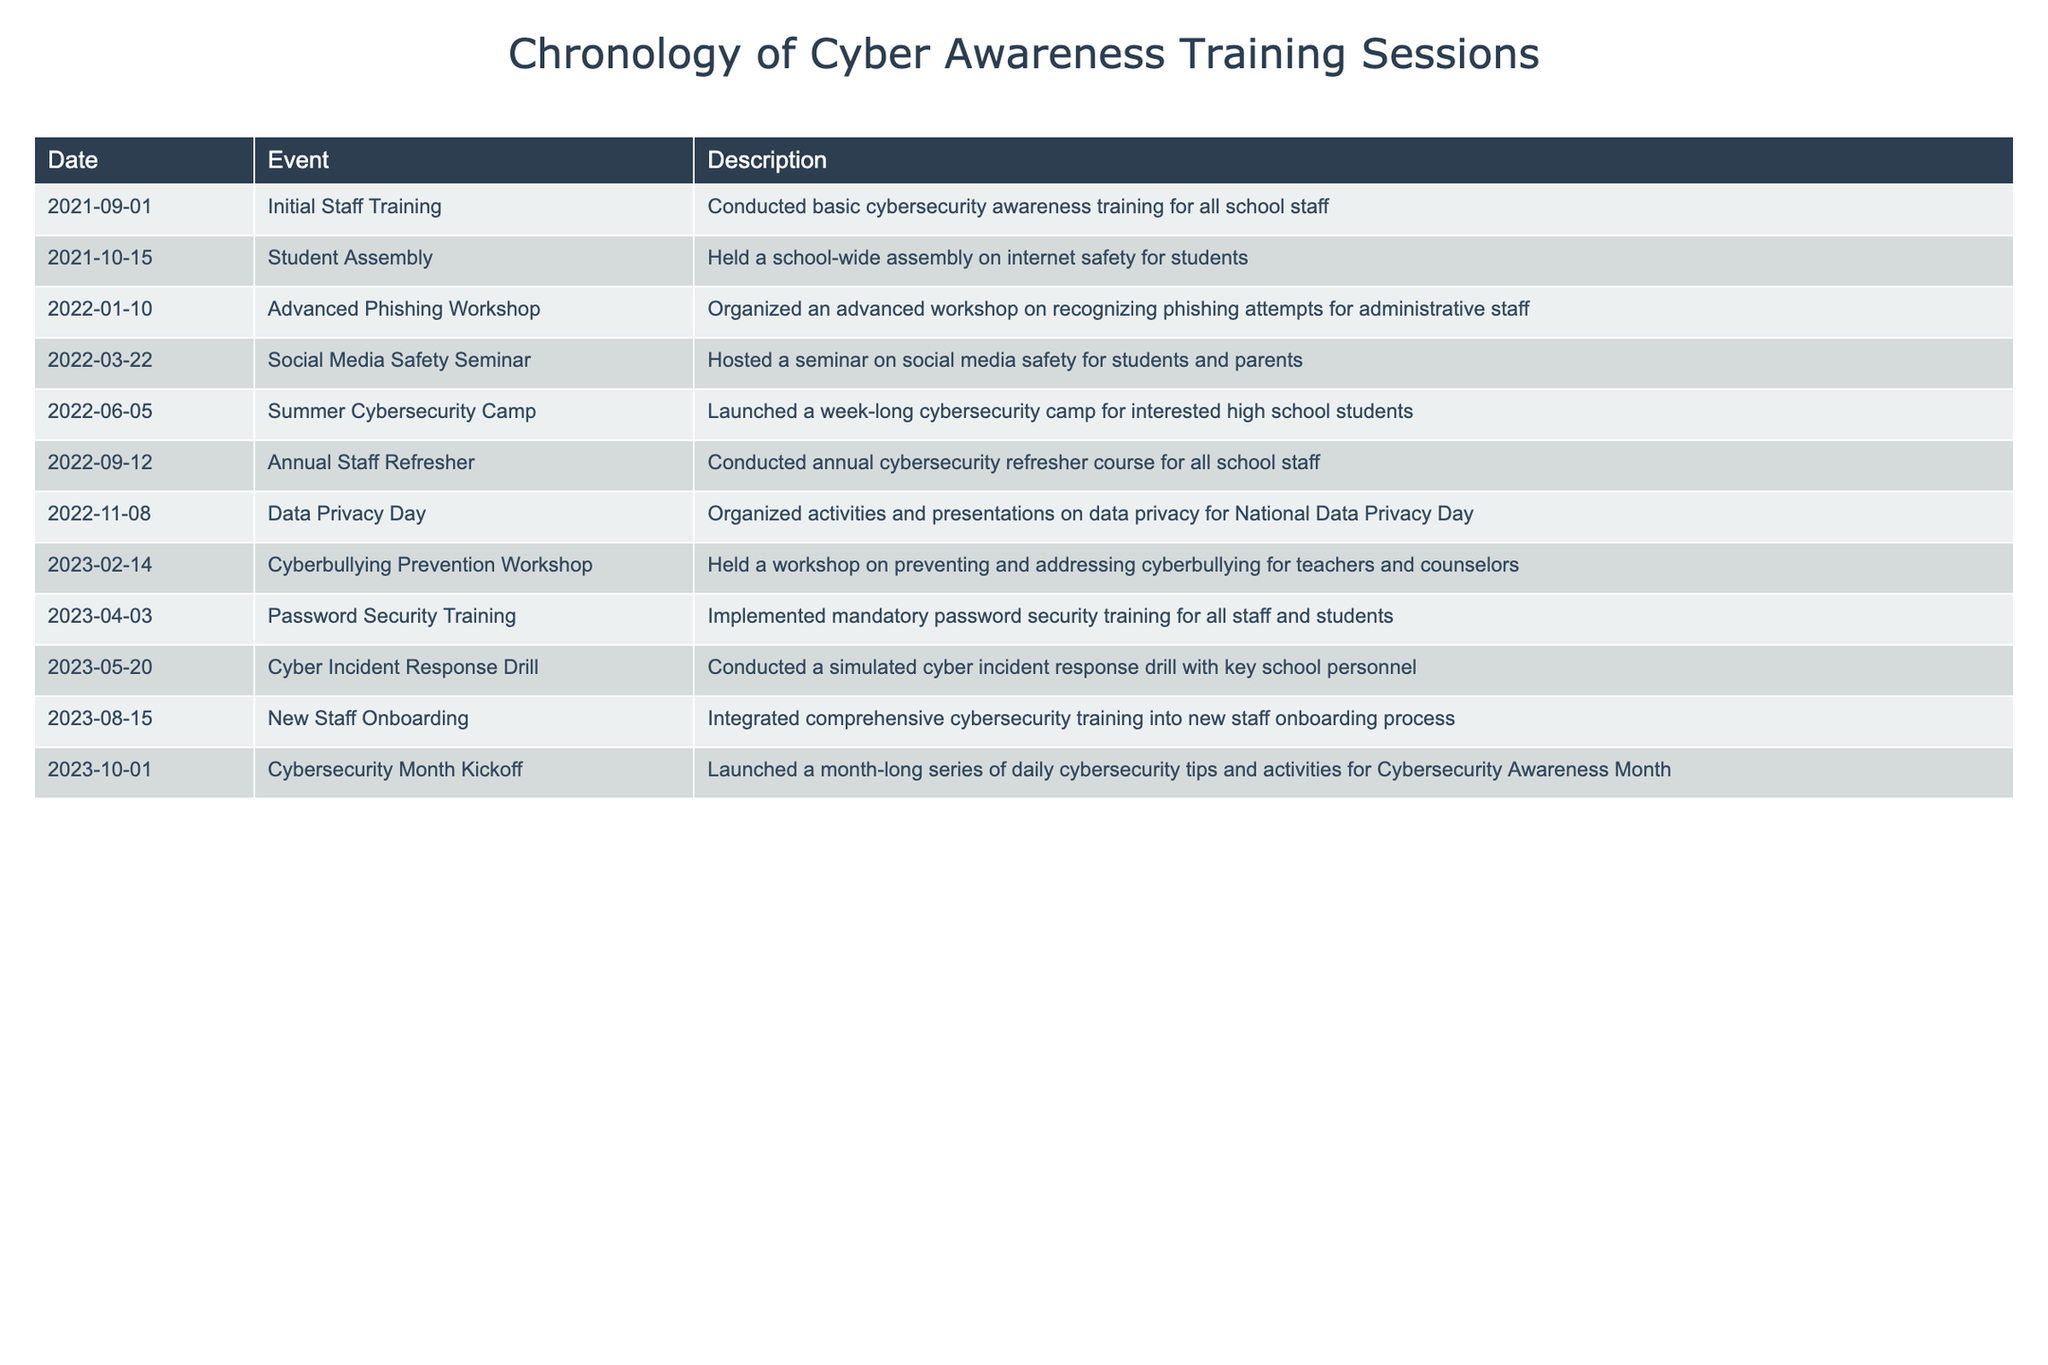What was the date of the first event listed in the table? The first event listed is "Initial Staff Training," which occurred on September 1, 2021. I can easily find this by looking at the "Date" column of the first row.
Answer: September 1, 2021 How many training sessions were conducted in 2022? I can count the events listed in 2022, which include: "Advanced Phishing Workshop," "Social Media Safety Seminar," "Summer Cybersecurity Camp," "Annual Staff Refresher," and "Data Privacy Day." This totals 5 events.
Answer: 5 Was there any training related to cyberbullying in 2023? Looking at the events in 2023, there is a workshop specifically titled "Cyberbullying Prevention Workshop" held on February 14, addressing this topic.
Answer: Yes What is the most recent event listed in the table? The most recent event is "Cybersecurity Month Kickoff," which took place on October 1, 2023. I can confirm this by checking the "Date" column of the last row.
Answer: October 1, 2023 How many months passed between the "Student Assembly" and the "Cyber Incident Response Drill"? The "Student Assembly" occurred on October 15, 2021, and the "Cyber Incident Response Drill" took place on May 20, 2023. First, I count the months: from October 2021 to October 2022 is 12 months, and from October 2022 to May 2023 is an additional 7 months. Therefore, the total difference is 19 months.
Answer: 19 months What percentage of events were held for students in the table? There are 10 events listed. Among these, the following events involve students: "Student Assembly," "Social Media Safety Seminar," "Summer Cybersecurity Camp," "Cyberbullying Prevention Workshop," and "Password Security Training." That totals 5 events for students. To find the percentage, I compute (5/10) * 100 = 50%.
Answer: 50% What type of training was held on June 5, 2022? The event on June 5, 2022, is titled "Summer Cybersecurity Camp," which is a training event intended for high school students.
Answer: Summer Cybersecurity Camp How many events included both staff and students? I will look for events that mention both staff and students. The "Password Security Training" and "Cyber Incident Response Drill" are for both groups. Therefore, there are 2 events that included both.
Answer: 2 